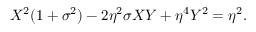<formula> <loc_0><loc_0><loc_500><loc_500>X ^ { 2 } ( 1 + \sigma ^ { 2 } ) - 2 \eta ^ { 2 } \sigma X Y + \eta ^ { 4 } Y ^ { 2 } = \eta ^ { 2 } .</formula> 